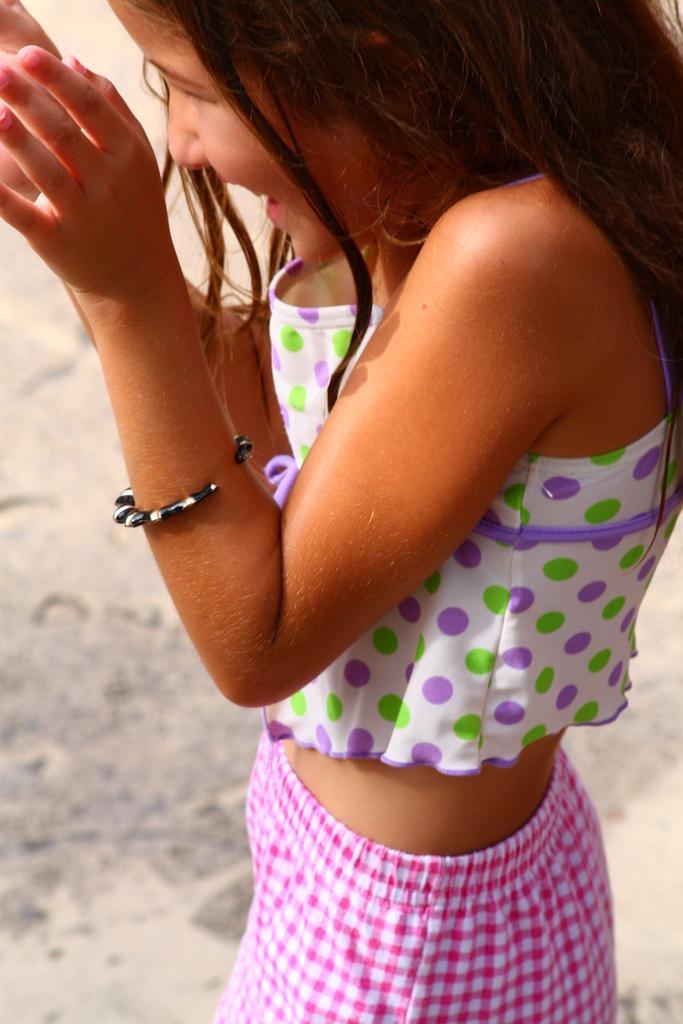Can you describe this image briefly? In this image we can see a girl. Behind the girl we can see the ground. 